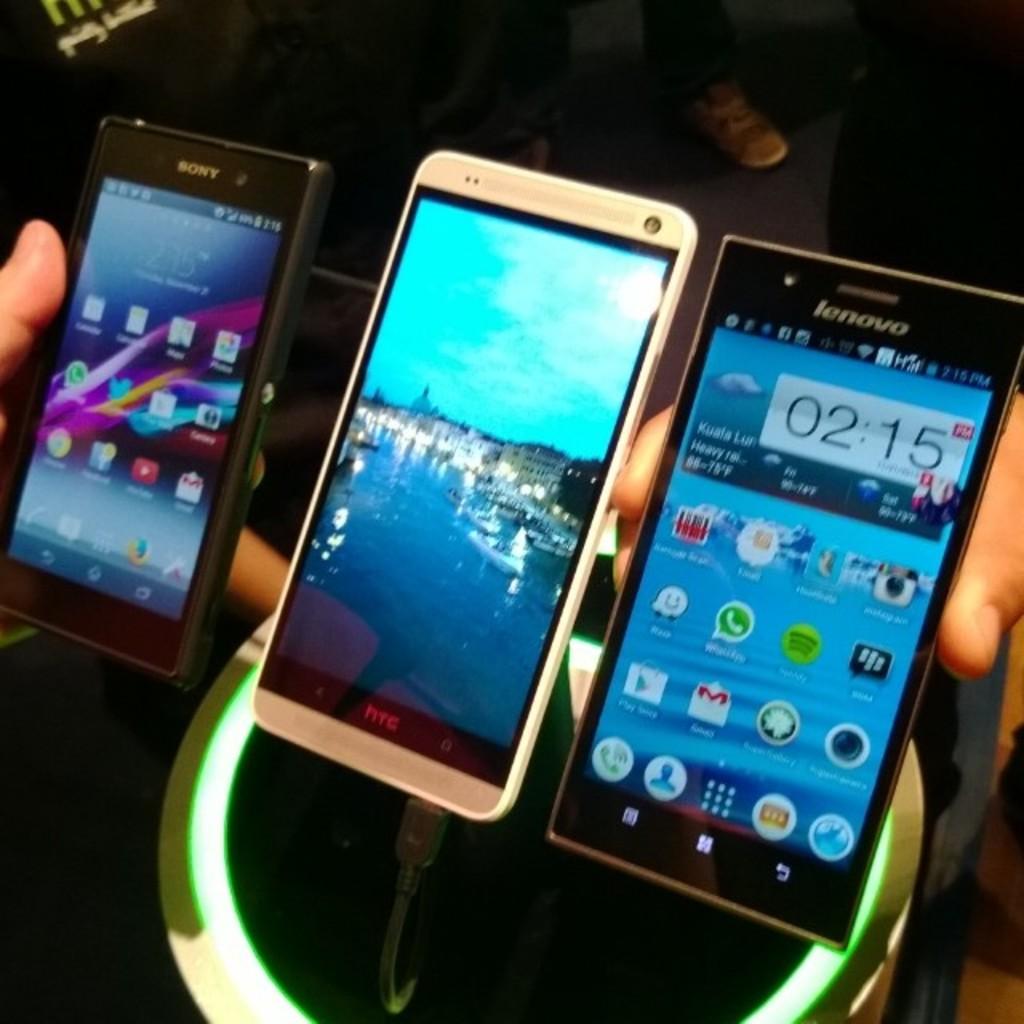What time is on the phone on the right?
Make the answer very short. 02:15. What brand is the phone in the middle?
Ensure brevity in your answer.  Htc. 